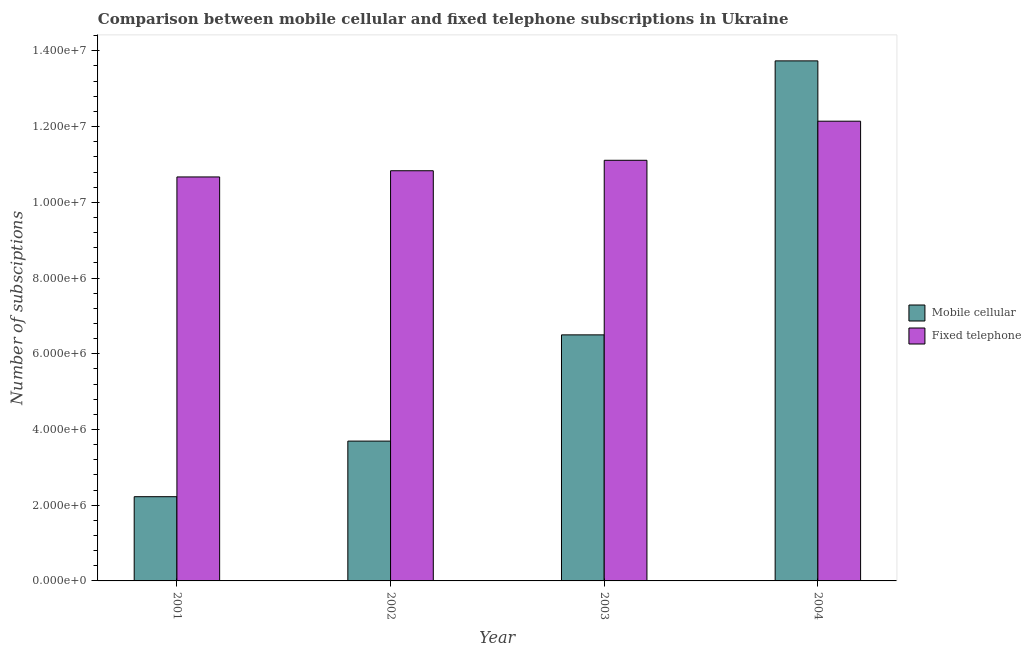How many groups of bars are there?
Your answer should be compact. 4. Are the number of bars per tick equal to the number of legend labels?
Ensure brevity in your answer.  Yes. Are the number of bars on each tick of the X-axis equal?
Give a very brief answer. Yes. What is the label of the 3rd group of bars from the left?
Make the answer very short. 2003. In how many cases, is the number of bars for a given year not equal to the number of legend labels?
Make the answer very short. 0. What is the number of fixed telephone subscriptions in 2001?
Keep it short and to the point. 1.07e+07. Across all years, what is the maximum number of fixed telephone subscriptions?
Your answer should be very brief. 1.21e+07. Across all years, what is the minimum number of mobile cellular subscriptions?
Provide a short and direct response. 2.22e+06. In which year was the number of fixed telephone subscriptions maximum?
Provide a succinct answer. 2004. What is the total number of mobile cellular subscriptions in the graph?
Your answer should be very brief. 2.62e+07. What is the difference between the number of fixed telephone subscriptions in 2002 and that in 2004?
Give a very brief answer. -1.31e+06. What is the difference between the number of fixed telephone subscriptions in 2003 and the number of mobile cellular subscriptions in 2004?
Your answer should be compact. -1.03e+06. What is the average number of mobile cellular subscriptions per year?
Offer a very short reply. 6.54e+06. In the year 2003, what is the difference between the number of fixed telephone subscriptions and number of mobile cellular subscriptions?
Your answer should be compact. 0. What is the ratio of the number of fixed telephone subscriptions in 2003 to that in 2004?
Ensure brevity in your answer.  0.91. What is the difference between the highest and the second highest number of fixed telephone subscriptions?
Your response must be concise. 1.03e+06. What is the difference between the highest and the lowest number of fixed telephone subscriptions?
Make the answer very short. 1.47e+06. In how many years, is the number of mobile cellular subscriptions greater than the average number of mobile cellular subscriptions taken over all years?
Keep it short and to the point. 1. What does the 2nd bar from the left in 2002 represents?
Ensure brevity in your answer.  Fixed telephone. What does the 1st bar from the right in 2001 represents?
Your answer should be compact. Fixed telephone. Are the values on the major ticks of Y-axis written in scientific E-notation?
Offer a very short reply. Yes. What is the title of the graph?
Ensure brevity in your answer.  Comparison between mobile cellular and fixed telephone subscriptions in Ukraine. Does "Time to import" appear as one of the legend labels in the graph?
Provide a short and direct response. No. What is the label or title of the Y-axis?
Offer a very short reply. Number of subsciptions. What is the Number of subsciptions in Mobile cellular in 2001?
Provide a succinct answer. 2.22e+06. What is the Number of subsciptions of Fixed telephone in 2001?
Provide a short and direct response. 1.07e+07. What is the Number of subsciptions in Mobile cellular in 2002?
Your response must be concise. 3.69e+06. What is the Number of subsciptions in Fixed telephone in 2002?
Keep it short and to the point. 1.08e+07. What is the Number of subsciptions in Mobile cellular in 2003?
Your response must be concise. 6.50e+06. What is the Number of subsciptions in Fixed telephone in 2003?
Your response must be concise. 1.11e+07. What is the Number of subsciptions in Mobile cellular in 2004?
Your answer should be very brief. 1.37e+07. What is the Number of subsciptions in Fixed telephone in 2004?
Provide a short and direct response. 1.21e+07. Across all years, what is the maximum Number of subsciptions in Mobile cellular?
Provide a succinct answer. 1.37e+07. Across all years, what is the maximum Number of subsciptions in Fixed telephone?
Offer a terse response. 1.21e+07. Across all years, what is the minimum Number of subsciptions in Mobile cellular?
Provide a succinct answer. 2.22e+06. Across all years, what is the minimum Number of subsciptions of Fixed telephone?
Your answer should be very brief. 1.07e+07. What is the total Number of subsciptions of Mobile cellular in the graph?
Make the answer very short. 2.62e+07. What is the total Number of subsciptions of Fixed telephone in the graph?
Provide a succinct answer. 4.48e+07. What is the difference between the Number of subsciptions of Mobile cellular in 2001 and that in 2002?
Your answer should be compact. -1.47e+06. What is the difference between the Number of subsciptions in Fixed telephone in 2001 and that in 2002?
Give a very brief answer. -1.64e+05. What is the difference between the Number of subsciptions of Mobile cellular in 2001 and that in 2003?
Your answer should be compact. -4.27e+06. What is the difference between the Number of subsciptions of Fixed telephone in 2001 and that in 2003?
Keep it short and to the point. -4.40e+05. What is the difference between the Number of subsciptions in Mobile cellular in 2001 and that in 2004?
Offer a very short reply. -1.15e+07. What is the difference between the Number of subsciptions in Fixed telephone in 2001 and that in 2004?
Give a very brief answer. -1.47e+06. What is the difference between the Number of subsciptions of Mobile cellular in 2002 and that in 2003?
Offer a very short reply. -2.81e+06. What is the difference between the Number of subsciptions of Fixed telephone in 2002 and that in 2003?
Offer a very short reply. -2.76e+05. What is the difference between the Number of subsciptions of Mobile cellular in 2002 and that in 2004?
Offer a terse response. -1.00e+07. What is the difference between the Number of subsciptions in Fixed telephone in 2002 and that in 2004?
Keep it short and to the point. -1.31e+06. What is the difference between the Number of subsciptions in Mobile cellular in 2003 and that in 2004?
Your answer should be very brief. -7.24e+06. What is the difference between the Number of subsciptions of Fixed telephone in 2003 and that in 2004?
Give a very brief answer. -1.03e+06. What is the difference between the Number of subsciptions of Mobile cellular in 2001 and the Number of subsciptions of Fixed telephone in 2002?
Give a very brief answer. -8.61e+06. What is the difference between the Number of subsciptions of Mobile cellular in 2001 and the Number of subsciptions of Fixed telephone in 2003?
Your answer should be compact. -8.88e+06. What is the difference between the Number of subsciptions of Mobile cellular in 2001 and the Number of subsciptions of Fixed telephone in 2004?
Provide a succinct answer. -9.92e+06. What is the difference between the Number of subsciptions of Mobile cellular in 2002 and the Number of subsciptions of Fixed telephone in 2003?
Ensure brevity in your answer.  -7.42e+06. What is the difference between the Number of subsciptions of Mobile cellular in 2002 and the Number of subsciptions of Fixed telephone in 2004?
Ensure brevity in your answer.  -8.45e+06. What is the difference between the Number of subsciptions in Mobile cellular in 2003 and the Number of subsciptions in Fixed telephone in 2004?
Ensure brevity in your answer.  -5.64e+06. What is the average Number of subsciptions in Mobile cellular per year?
Offer a terse response. 6.54e+06. What is the average Number of subsciptions in Fixed telephone per year?
Provide a short and direct response. 1.12e+07. In the year 2001, what is the difference between the Number of subsciptions in Mobile cellular and Number of subsciptions in Fixed telephone?
Ensure brevity in your answer.  -8.44e+06. In the year 2002, what is the difference between the Number of subsciptions of Mobile cellular and Number of subsciptions of Fixed telephone?
Ensure brevity in your answer.  -7.14e+06. In the year 2003, what is the difference between the Number of subsciptions in Mobile cellular and Number of subsciptions in Fixed telephone?
Your response must be concise. -4.61e+06. In the year 2004, what is the difference between the Number of subsciptions in Mobile cellular and Number of subsciptions in Fixed telephone?
Offer a terse response. 1.59e+06. What is the ratio of the Number of subsciptions in Mobile cellular in 2001 to that in 2002?
Give a very brief answer. 0.6. What is the ratio of the Number of subsciptions in Fixed telephone in 2001 to that in 2002?
Make the answer very short. 0.98. What is the ratio of the Number of subsciptions in Mobile cellular in 2001 to that in 2003?
Provide a succinct answer. 0.34. What is the ratio of the Number of subsciptions in Fixed telephone in 2001 to that in 2003?
Keep it short and to the point. 0.96. What is the ratio of the Number of subsciptions in Mobile cellular in 2001 to that in 2004?
Provide a succinct answer. 0.16. What is the ratio of the Number of subsciptions of Fixed telephone in 2001 to that in 2004?
Provide a short and direct response. 0.88. What is the ratio of the Number of subsciptions of Mobile cellular in 2002 to that in 2003?
Your response must be concise. 0.57. What is the ratio of the Number of subsciptions in Fixed telephone in 2002 to that in 2003?
Keep it short and to the point. 0.98. What is the ratio of the Number of subsciptions in Mobile cellular in 2002 to that in 2004?
Give a very brief answer. 0.27. What is the ratio of the Number of subsciptions in Fixed telephone in 2002 to that in 2004?
Your answer should be very brief. 0.89. What is the ratio of the Number of subsciptions in Mobile cellular in 2003 to that in 2004?
Your response must be concise. 0.47. What is the ratio of the Number of subsciptions in Fixed telephone in 2003 to that in 2004?
Keep it short and to the point. 0.92. What is the difference between the highest and the second highest Number of subsciptions of Mobile cellular?
Keep it short and to the point. 7.24e+06. What is the difference between the highest and the second highest Number of subsciptions of Fixed telephone?
Ensure brevity in your answer.  1.03e+06. What is the difference between the highest and the lowest Number of subsciptions of Mobile cellular?
Keep it short and to the point. 1.15e+07. What is the difference between the highest and the lowest Number of subsciptions in Fixed telephone?
Provide a succinct answer. 1.47e+06. 